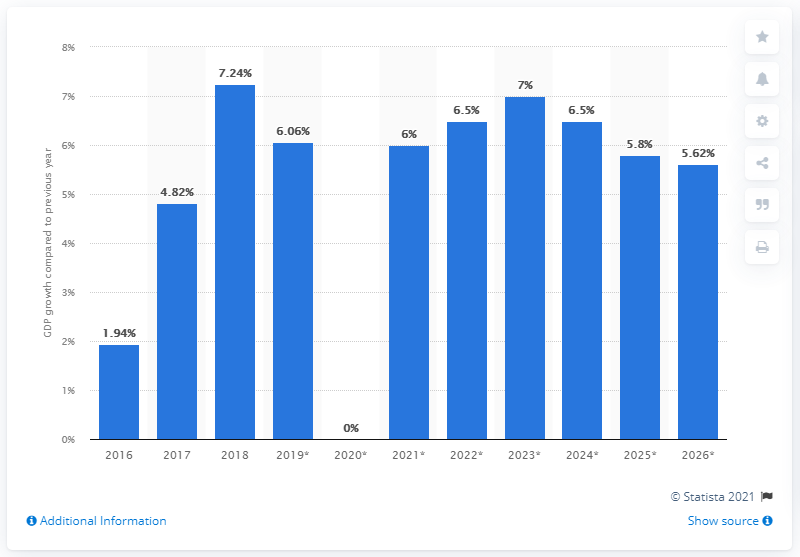Point out several critical features in this image. In 2018, the real Gross Domestic Product (GDP) of the Gambia grew by 7.24%. 